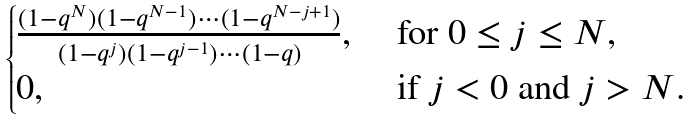Convert formula to latex. <formula><loc_0><loc_0><loc_500><loc_500>\begin{cases} \frac { ( 1 - q ^ { N } ) ( 1 - q ^ { N - 1 } ) \cdots ( 1 - q ^ { N - j + 1 } ) } { ( 1 - q ^ { j } ) ( 1 - q ^ { j - 1 } ) \cdots ( 1 - q ) } , & \text { for $0\leq j\leq N$,} \\ 0 , & \text { if $j<0$ and $j>N$.} \end{cases}</formula> 